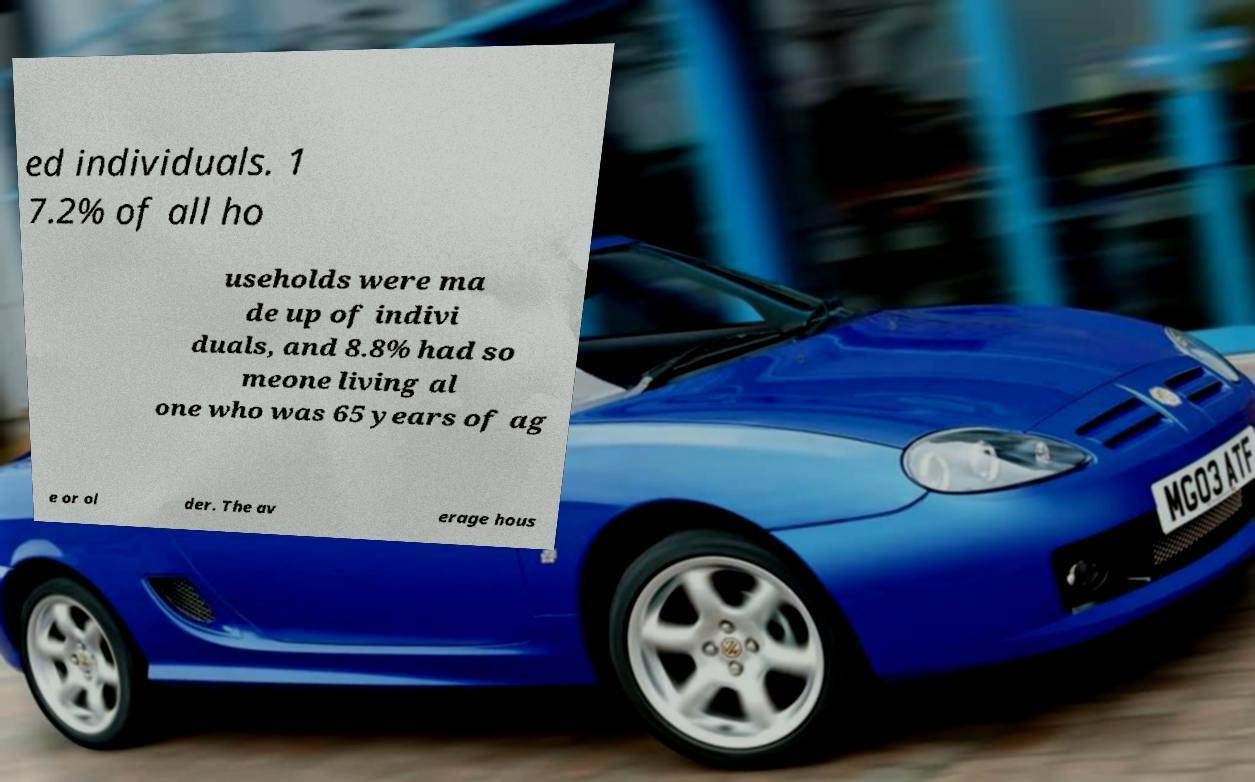For documentation purposes, I need the text within this image transcribed. Could you provide that? ed individuals. 1 7.2% of all ho useholds were ma de up of indivi duals, and 8.8% had so meone living al one who was 65 years of ag e or ol der. The av erage hous 